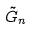Convert formula to latex. <formula><loc_0><loc_0><loc_500><loc_500>\tilde { G } _ { n }</formula> 